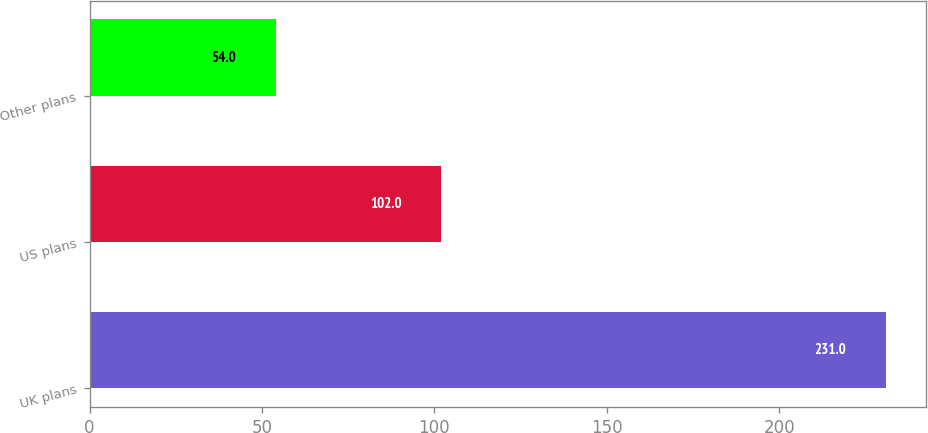Convert chart to OTSL. <chart><loc_0><loc_0><loc_500><loc_500><bar_chart><fcel>UK plans<fcel>US plans<fcel>Other plans<nl><fcel>231<fcel>102<fcel>54<nl></chart> 